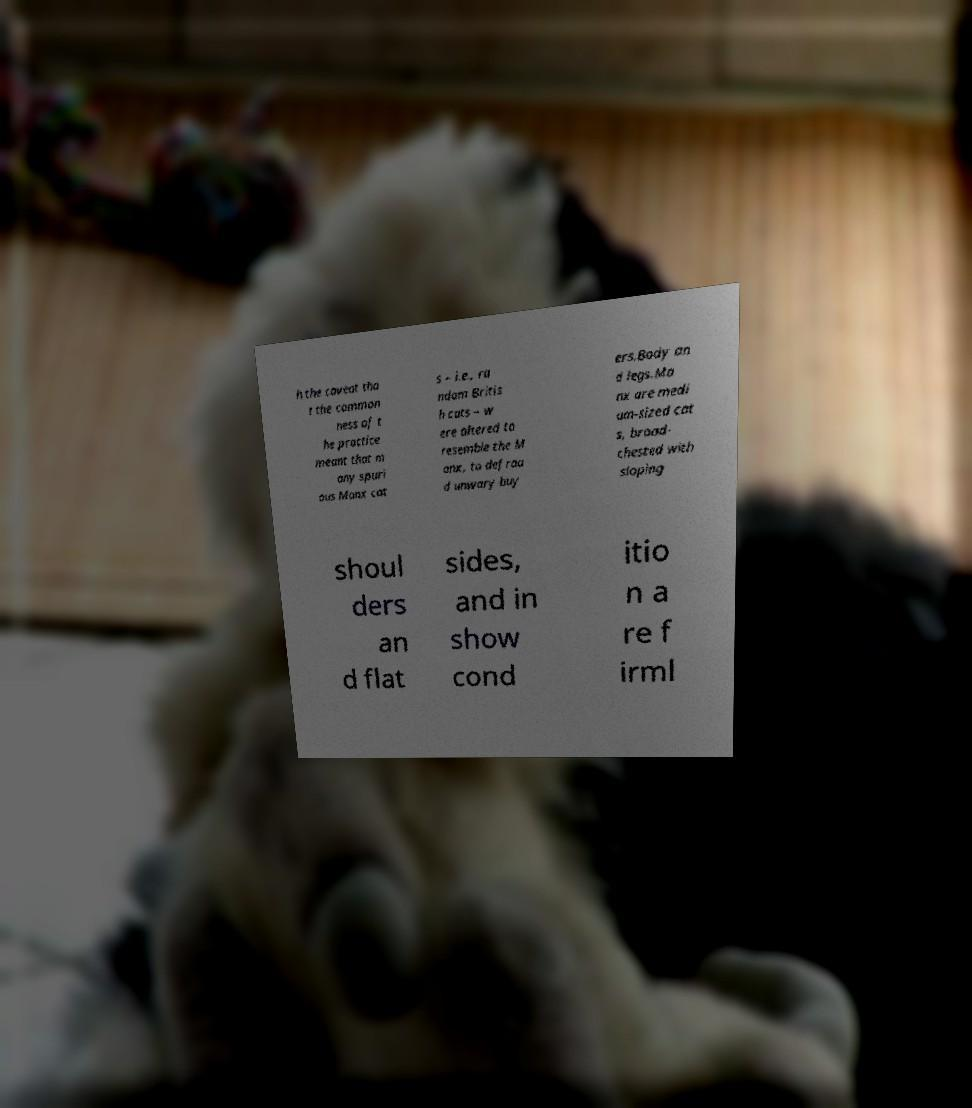Could you assist in decoding the text presented in this image and type it out clearly? h the caveat tha t the common ness of t he practice meant that m any spuri ous Manx cat s – i.e., ra ndom Britis h cats – w ere altered to resemble the M anx, to defrau d unwary buy ers.Body an d legs.Ma nx are medi um-sized cat s, broad- chested with sloping shoul ders an d flat sides, and in show cond itio n a re f irml 